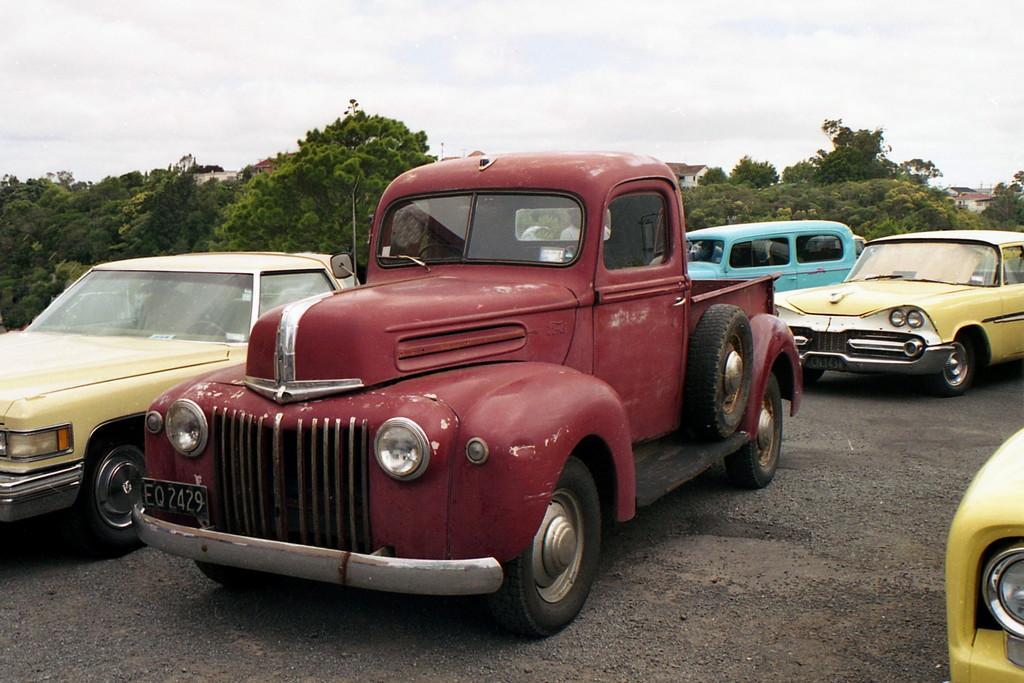Please provide a concise description of this image. In the picture we can see some vintage cars are parked on the path, some are yellow in color, one is blue in color and one is red in color and in the background we can see full of trees and a sky with clouds. 